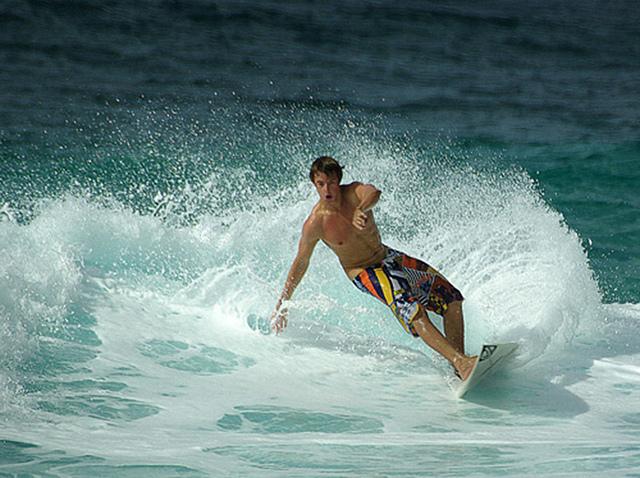What color are his shorts?
Short answer required. Multi colored. Is this person wearing a wetsuit?
Concise answer only. No. What color is the water?
Short answer required. Blue. Is the boy on a boogie board?
Keep it brief. No. 